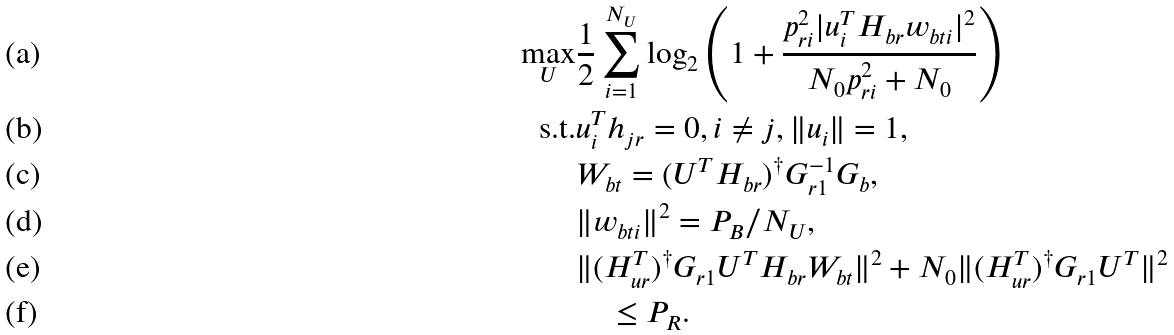<formula> <loc_0><loc_0><loc_500><loc_500>\underset { U } { \max } & \frac { 1 } { 2 } \sum _ { i = 1 } ^ { N _ { U } } \log _ { 2 } \left ( 1 + \frac { p _ { r i } ^ { 2 } | u _ { i } ^ { T } H _ { b r } w _ { b t i } | ^ { 2 } } { N _ { 0 } p _ { r i } ^ { 2 } + N _ { 0 } } \right ) \\ \text {s.t.} & u _ { i } ^ { T } h _ { j r } = 0 , i \not = j , \| u _ { i } \| = 1 , \\ & W _ { b t } = ( U ^ { T } H _ { b r } ) ^ { \dagger } G _ { r 1 } ^ { - 1 } G _ { b } , \\ & \| w _ { b t i } \| ^ { 2 } = P _ { B } / N _ { U } , \\ & \| ( H _ { u r } ^ { T } ) ^ { \dag } G _ { r 1 } U ^ { T } H _ { b r } W _ { b t } \| ^ { 2 } + N _ { 0 } \| ( H _ { u r } ^ { T } ) ^ { \dag } G _ { r 1 } U ^ { T } \| ^ { 2 } \\ & \quad \leq P _ { R } .</formula> 